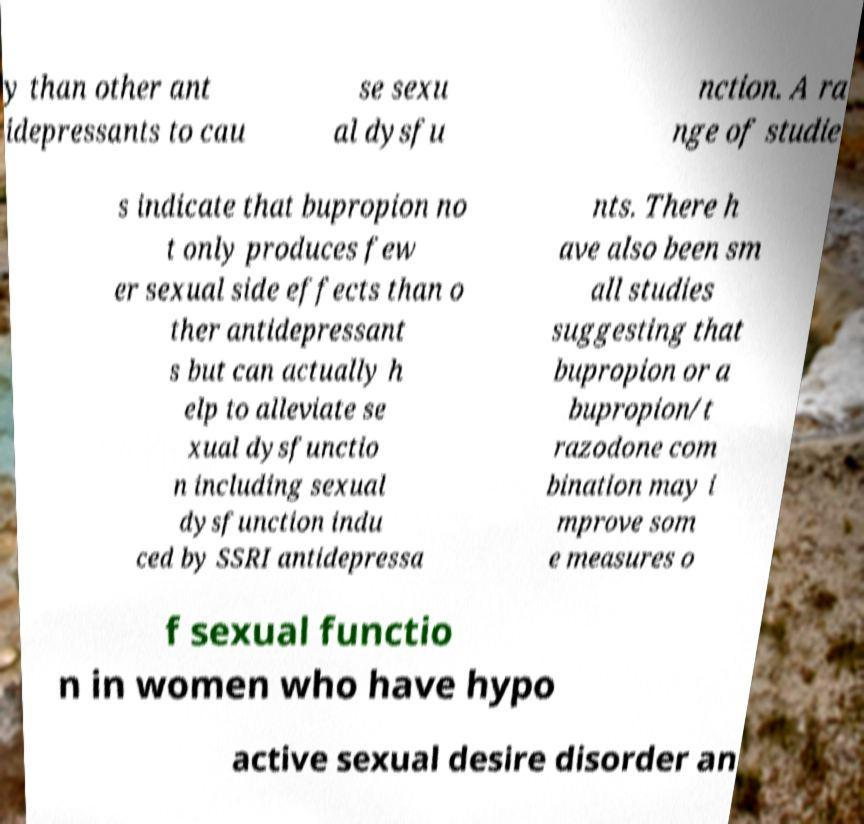Can you read and provide the text displayed in the image?This photo seems to have some interesting text. Can you extract and type it out for me? y than other ant idepressants to cau se sexu al dysfu nction. A ra nge of studie s indicate that bupropion no t only produces few er sexual side effects than o ther antidepressant s but can actually h elp to alleviate se xual dysfunctio n including sexual dysfunction indu ced by SSRI antidepressa nts. There h ave also been sm all studies suggesting that bupropion or a bupropion/t razodone com bination may i mprove som e measures o f sexual functio n in women who have hypo active sexual desire disorder an 